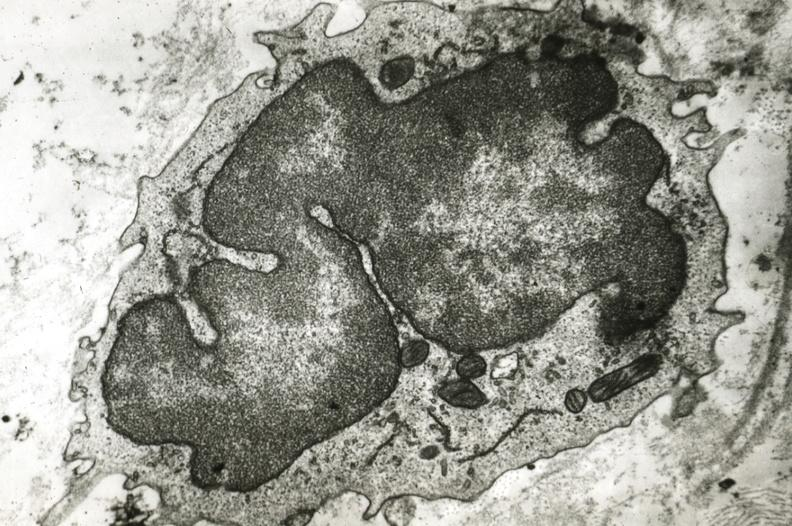where is this?
Answer the question using a single word or phrase. Vasculature 